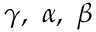Convert formula to latex. <formula><loc_0><loc_0><loc_500><loc_500>\gamma , \alpha , \beta</formula> 